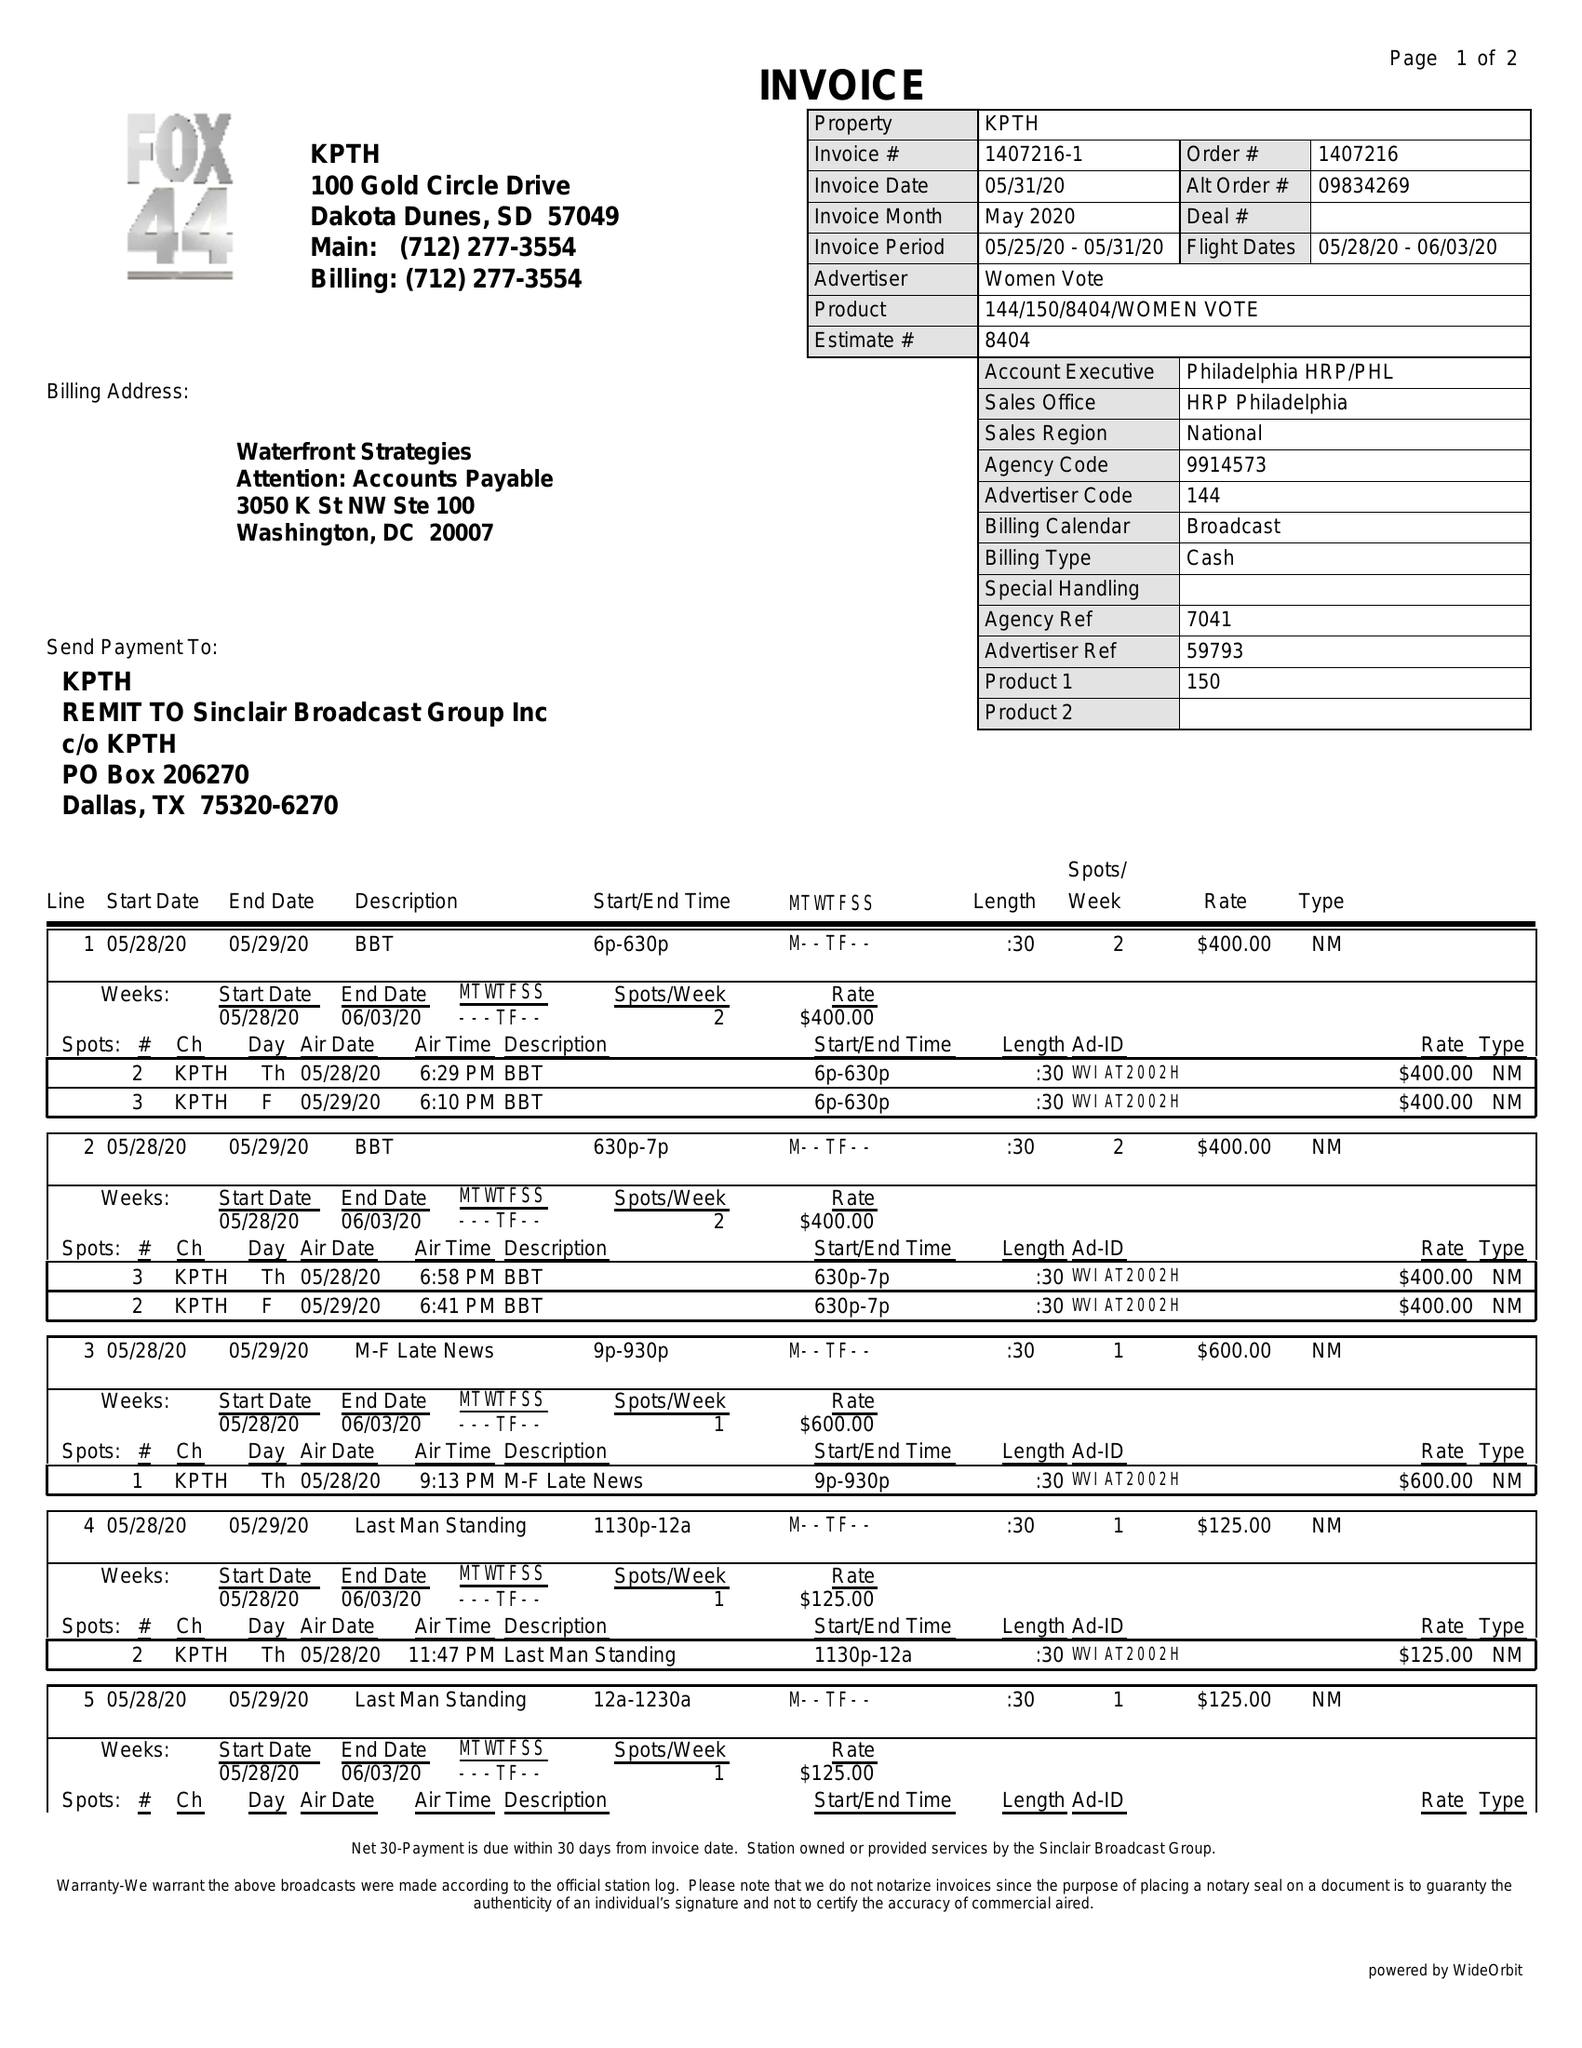What is the value for the advertiser?
Answer the question using a single word or phrase. WOMEN VOTE 